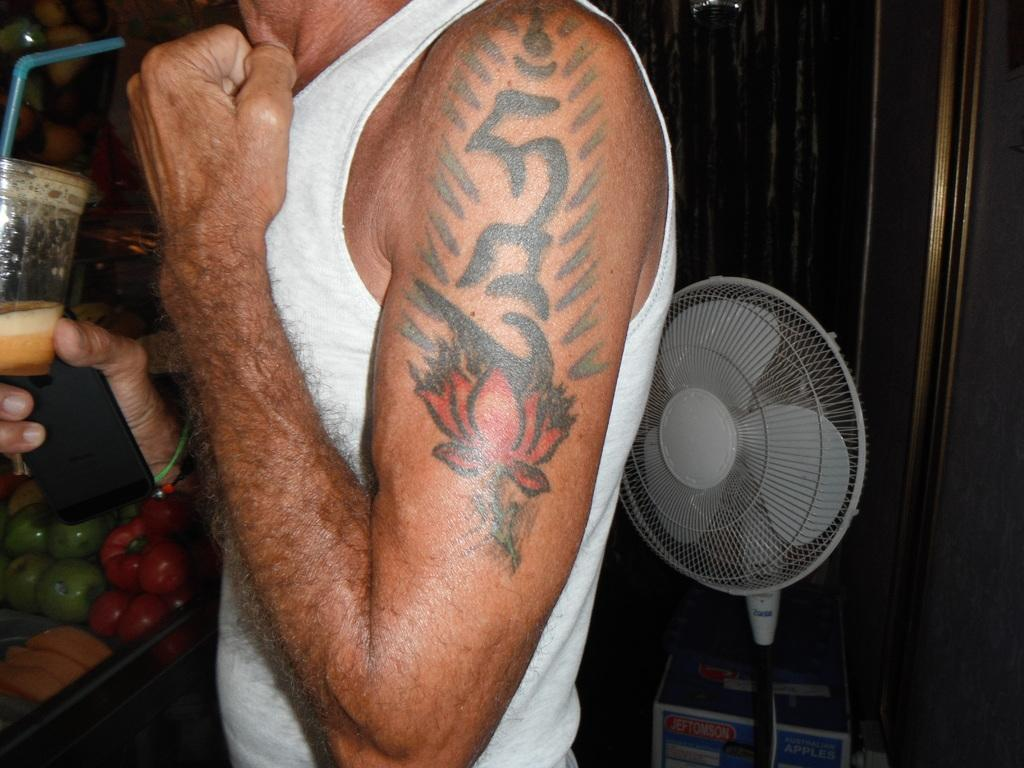What is the main subject of the image? There is a man in the image. What is the man doing in the image? The man is standing in the image. What objects is the man holding in his hands? The man is holding a glass and a mobile in his hands. What additional object can be seen in the image? There is a table fan visible in the image. What type of rail is the man using to support the cabbage in the image? There is no rail or cabbage present in the image. 